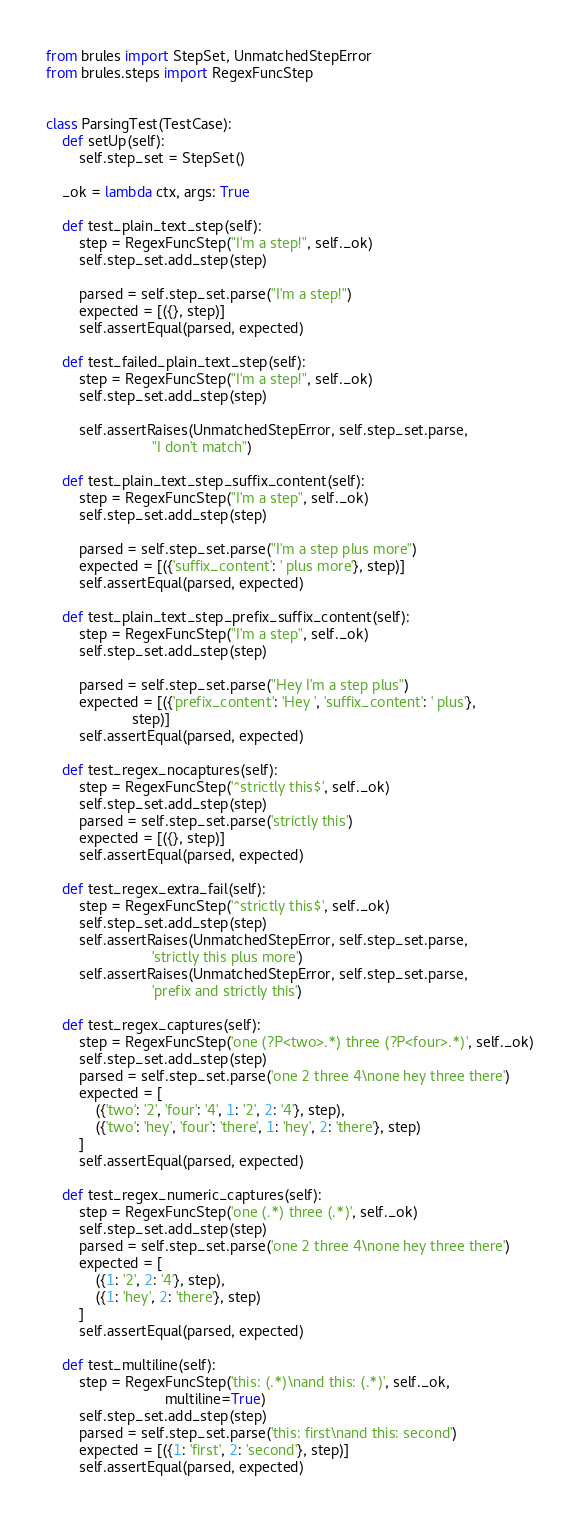<code> <loc_0><loc_0><loc_500><loc_500><_Python_>from brules import StepSet, UnmatchedStepError
from brules.steps import RegexFuncStep


class ParsingTest(TestCase):
    def setUp(self):
        self.step_set = StepSet()

    _ok = lambda ctx, args: True

    def test_plain_text_step(self):
        step = RegexFuncStep("I'm a step!", self._ok)
        self.step_set.add_step(step)

        parsed = self.step_set.parse("I'm a step!")
        expected = [({}, step)]
        self.assertEqual(parsed, expected)

    def test_failed_plain_text_step(self):
        step = RegexFuncStep("I'm a step!", self._ok)
        self.step_set.add_step(step)

        self.assertRaises(UnmatchedStepError, self.step_set.parse,
                          "I don't match")

    def test_plain_text_step_suffix_content(self):
        step = RegexFuncStep("I'm a step", self._ok)
        self.step_set.add_step(step)

        parsed = self.step_set.parse("I'm a step plus more")
        expected = [({'suffix_content': ' plus more'}, step)]
        self.assertEqual(parsed, expected)

    def test_plain_text_step_prefix_suffix_content(self):
        step = RegexFuncStep("I'm a step", self._ok)
        self.step_set.add_step(step)

        parsed = self.step_set.parse("Hey I'm a step plus")
        expected = [({'prefix_content': 'Hey ', 'suffix_content': ' plus'},
                     step)]
        self.assertEqual(parsed, expected)

    def test_regex_nocaptures(self):
        step = RegexFuncStep('^strictly this$', self._ok)
        self.step_set.add_step(step)
        parsed = self.step_set.parse('strictly this')
        expected = [({}, step)]
        self.assertEqual(parsed, expected)

    def test_regex_extra_fail(self):
        step = RegexFuncStep('^strictly this$', self._ok)
        self.step_set.add_step(step)
        self.assertRaises(UnmatchedStepError, self.step_set.parse,
                          'strictly this plus more')
        self.assertRaises(UnmatchedStepError, self.step_set.parse,
                          'prefix and strictly this')

    def test_regex_captures(self):
        step = RegexFuncStep('one (?P<two>.*) three (?P<four>.*)', self._ok)
        self.step_set.add_step(step)
        parsed = self.step_set.parse('one 2 three 4\none hey three there')
        expected = [
            ({'two': '2', 'four': '4', 1: '2', 2: '4'}, step),
            ({'two': 'hey', 'four': 'there', 1: 'hey', 2: 'there'}, step)
        ]
        self.assertEqual(parsed, expected)

    def test_regex_numeric_captures(self):
        step = RegexFuncStep('one (.*) three (.*)', self._ok)
        self.step_set.add_step(step)
        parsed = self.step_set.parse('one 2 three 4\none hey three there')
        expected = [
            ({1: '2', 2: '4'}, step),
            ({1: 'hey', 2: 'there'}, step)
        ]
        self.assertEqual(parsed, expected)

    def test_multiline(self):
        step = RegexFuncStep('this: (.*)\nand this: (.*)', self._ok,
                             multiline=True)
        self.step_set.add_step(step)
        parsed = self.step_set.parse('this: first\nand this: second')
        expected = [({1: 'first', 2: 'second'}, step)]
        self.assertEqual(parsed, expected)
</code> 